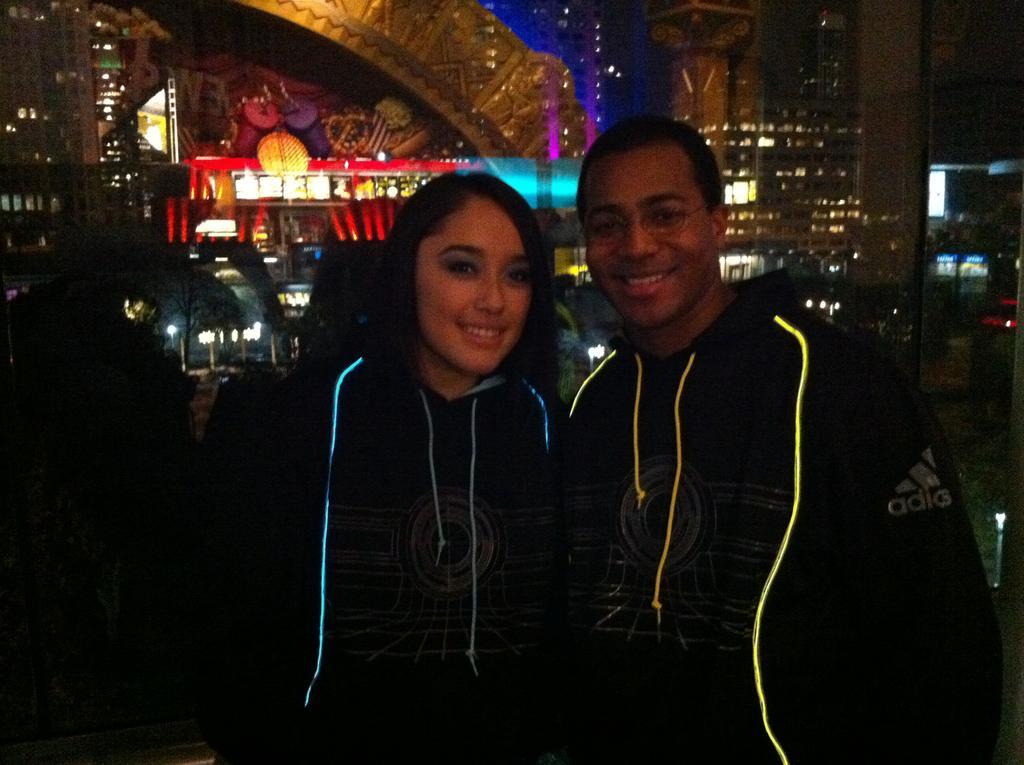Could you give a brief overview of what you see in this image? This picture is clicked inside. In the foreground we can see the two persons smiling, wearing hoodies and standing. In the background we can see the lights and many other objects. 